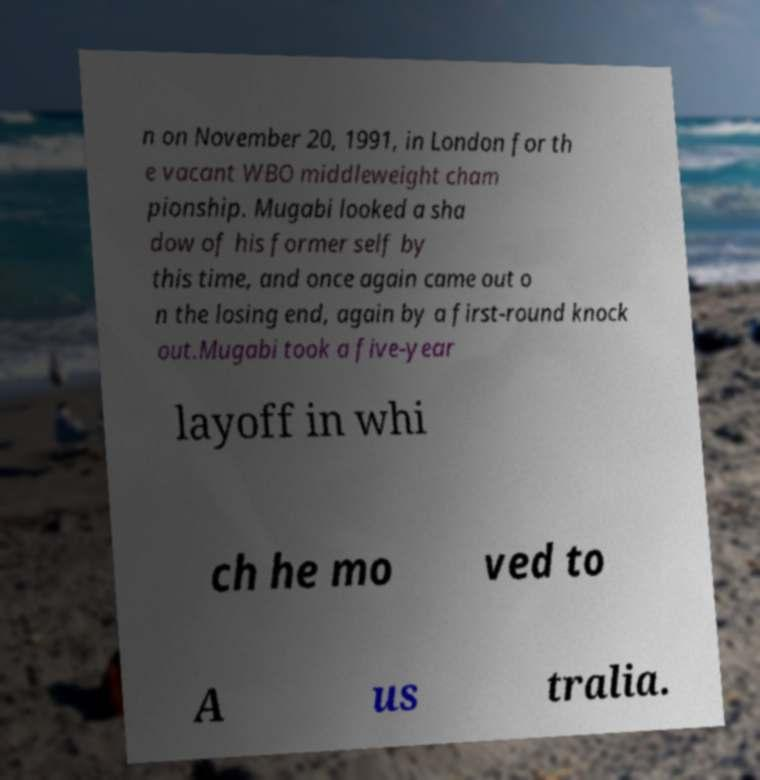Could you extract and type out the text from this image? n on November 20, 1991, in London for th e vacant WBO middleweight cham pionship. Mugabi looked a sha dow of his former self by this time, and once again came out o n the losing end, again by a first-round knock out.Mugabi took a five-year layoff in whi ch he mo ved to A us tralia. 